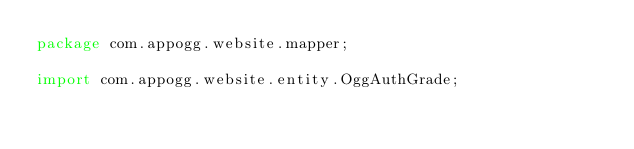<code> <loc_0><loc_0><loc_500><loc_500><_Java_>package com.appogg.website.mapper;

import com.appogg.website.entity.OggAuthGrade;</code> 